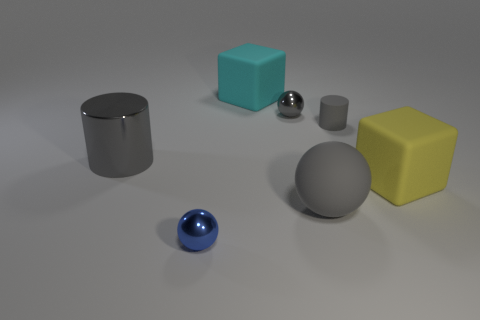Subtract all shiny balls. How many balls are left? 1 Add 3 blue objects. How many objects exist? 10 Subtract 1 cylinders. How many cylinders are left? 1 Subtract 0 yellow cylinders. How many objects are left? 7 Subtract all spheres. How many objects are left? 4 Subtract all purple blocks. Subtract all purple cylinders. How many blocks are left? 2 Subtract all cyan balls. How many red cylinders are left? 0 Subtract all matte things. Subtract all large shiny cylinders. How many objects are left? 2 Add 7 big yellow things. How many big yellow things are left? 8 Add 1 big cyan matte blocks. How many big cyan matte blocks exist? 2 